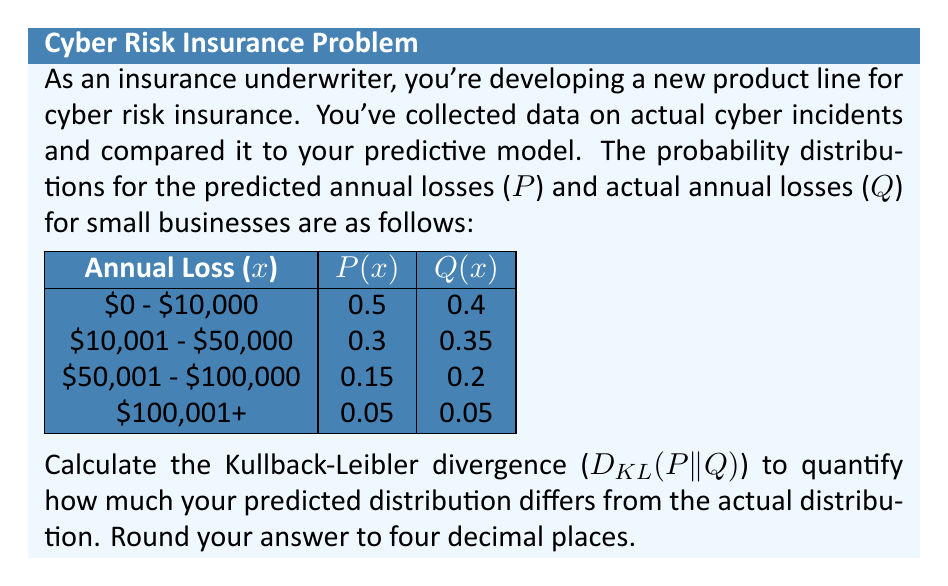What is the answer to this math problem? To calculate the Kullback-Leibler divergence between the predicted distribution P and the actual distribution Q, we use the formula:

$$D_{KL}(P||Q) = \sum_{i} P(x_i) \log\left(\frac{P(x_i)}{Q(x_i)}\right)$$

Let's calculate this step by step:

1) For $x_1$ ($0 - $10,000):
   $$P(x_1) \log\left(\frac{P(x_1)}{Q(x_1)}\right) = 0.5 \log\left(\frac{0.5}{0.4}\right) = 0.5 \log(1.25) = 0.5 \times 0.2231 = 0.1116$$

2) For $x_2$ ($10,001 - $50,000):
   $$P(x_2) \log\left(\frac{P(x_2)}{Q(x_2)}\right) = 0.3 \log\left(\frac{0.3}{0.35}\right) = 0.3 \log(0.8571) = 0.3 \times (-0.1542) = -0.0463$$

3) For $x_3$ ($50,001 - $100,000):
   $$P(x_3) \log\left(\frac{P(x_3)}{Q(x_3)}\right) = 0.15 \log\left(\frac{0.15}{0.2}\right) = 0.15 \log(0.75) = 0.15 \times (-0.2877) = -0.0432$$

4) For $x_4$ ($100,001+):
   $$P(x_4) \log\left(\frac{P(x_4)}{Q(x_4)}\right) = 0.05 \log\left(\frac{0.05}{0.05}\right) = 0.05 \log(1) = 0$$

5) Sum all these values:
   $$D_{KL}(P||Q) = 0.1116 - 0.0463 - 0.0432 + 0 = 0.0221$$

6) Rounding to four decimal places: 0.0221
Answer: 0.0221 